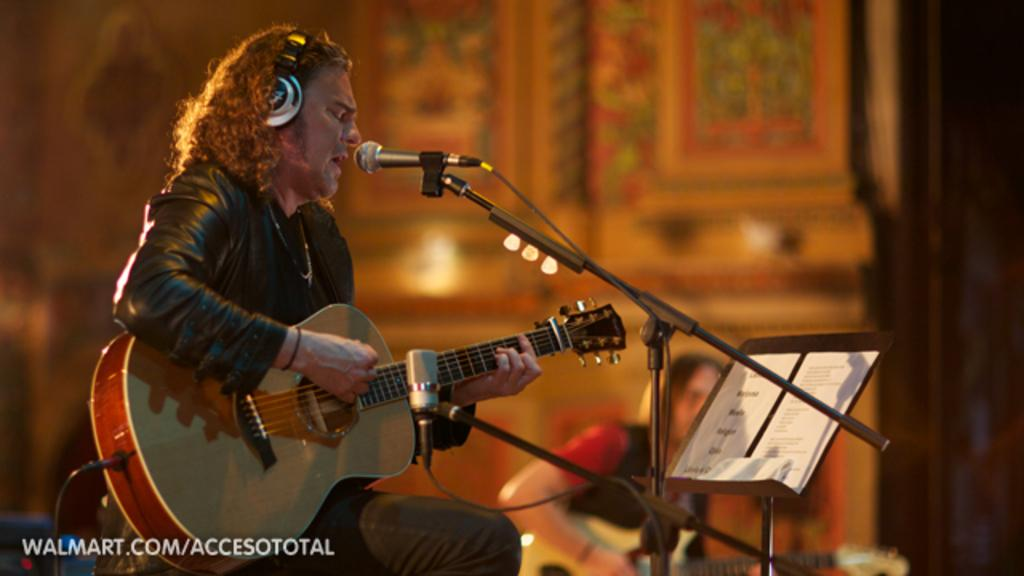What is the man in the image doing? The man is sitting and singing in the image. What instrument is the man holding? The man is holding a guitar in the image. What device is present for amplifying the man's voice? There is a microphone in the image. How is the microphone supported in the image? There is a microphone stand in the image. What additional object can be seen in the image? There is a board in the image. Can you see a coach in the image? No, there is no coach present in the image. Is the man singing in the wilderness? The image does not provide information about the location of the man, but it does not show any wilderness; it only shows the man, his guitar, the microphone, the microphone stand, and the board. 